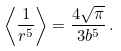Convert formula to latex. <formula><loc_0><loc_0><loc_500><loc_500>\left \langle \frac { 1 } { r ^ { 5 } } \right \rangle = \frac { 4 \sqrt { \pi } } { 3 b ^ { 5 } } \, .</formula> 